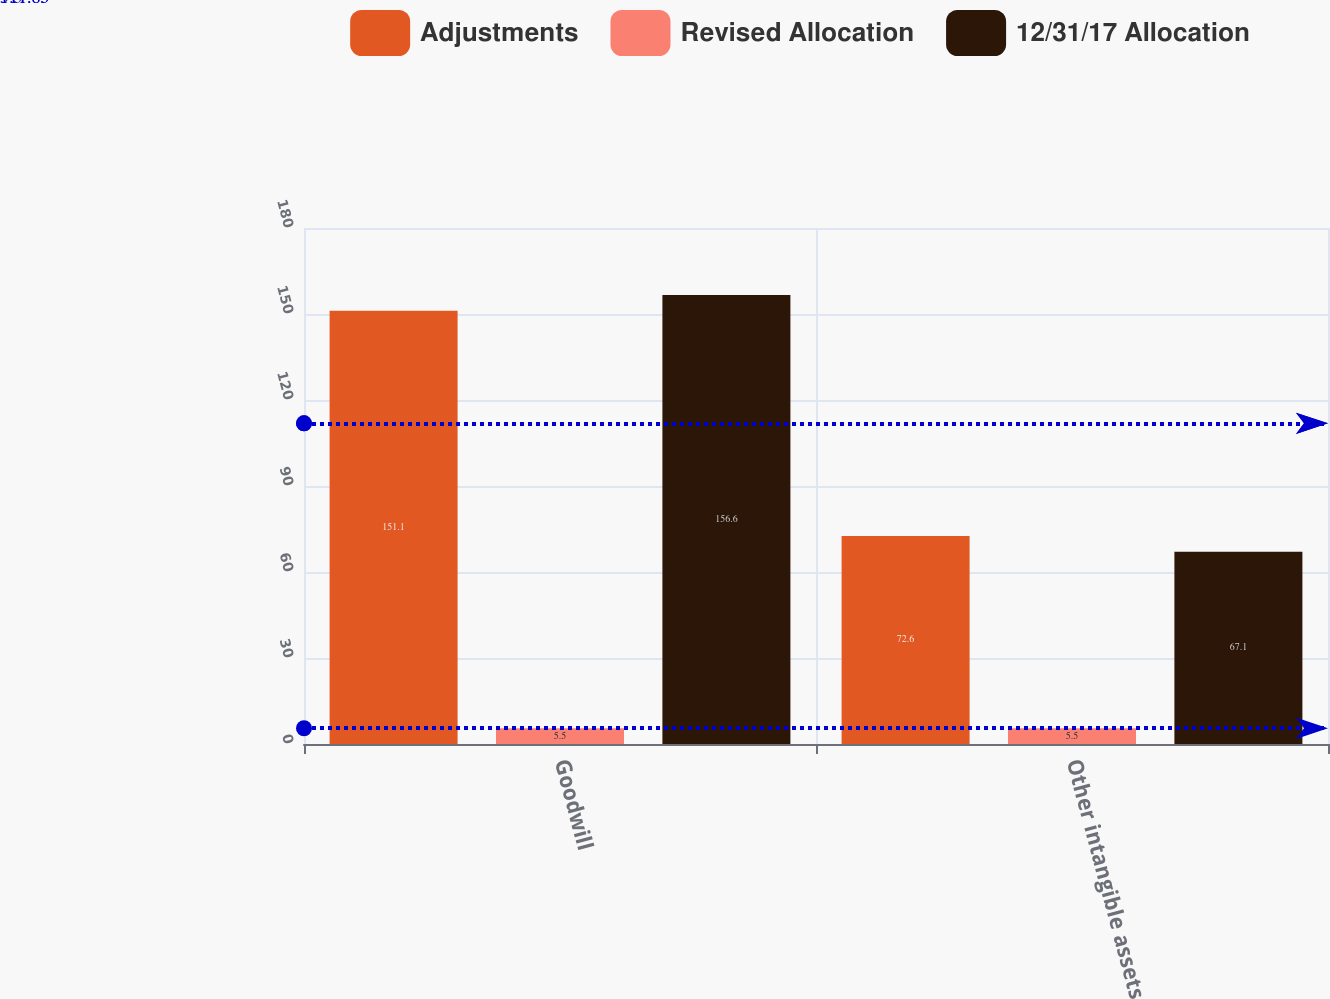Convert chart to OTSL. <chart><loc_0><loc_0><loc_500><loc_500><stacked_bar_chart><ecel><fcel>Goodwill<fcel>Other intangible assets<nl><fcel>Adjustments<fcel>151.1<fcel>72.6<nl><fcel>Revised Allocation<fcel>5.5<fcel>5.5<nl><fcel>12/31/17 Allocation<fcel>156.6<fcel>67.1<nl></chart> 